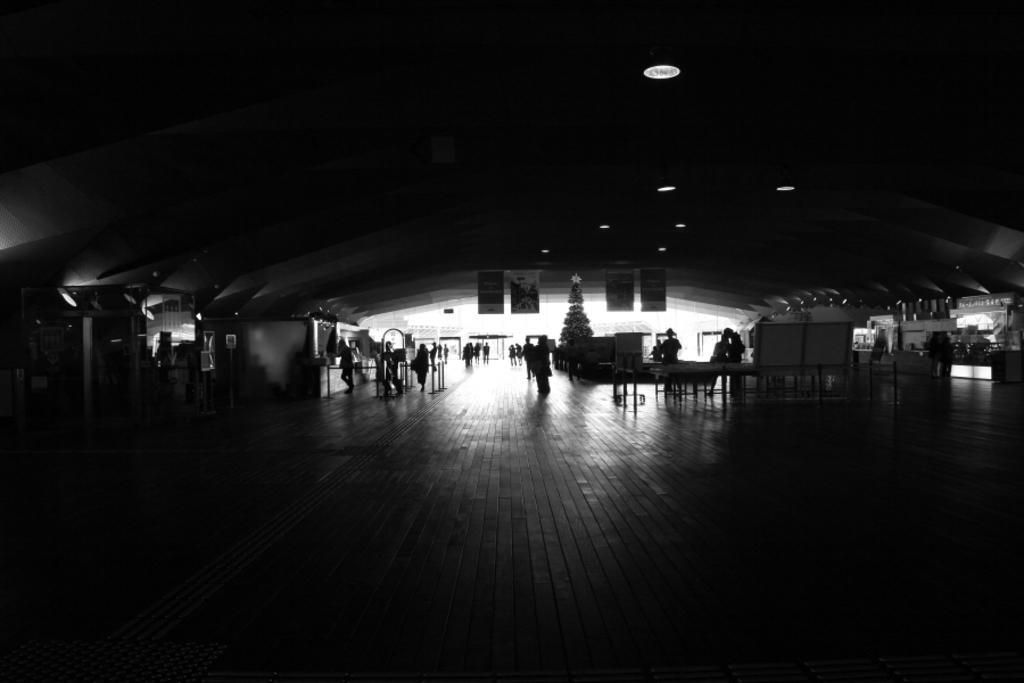What is the overall lighting condition in the image? The image is dark. Despite the darkness, what can be seen illuminated in the image? There are lights visible at the top of the image. What type of decorations are present in the image? There are posters in the image. What can be seen in the background of the image? There are people, tables, and a Christmas tree in the background of the image. What type of steam is coming from the birthday cake in the image? There is no birthday cake present in the image, and therefore no steam can be observed. 